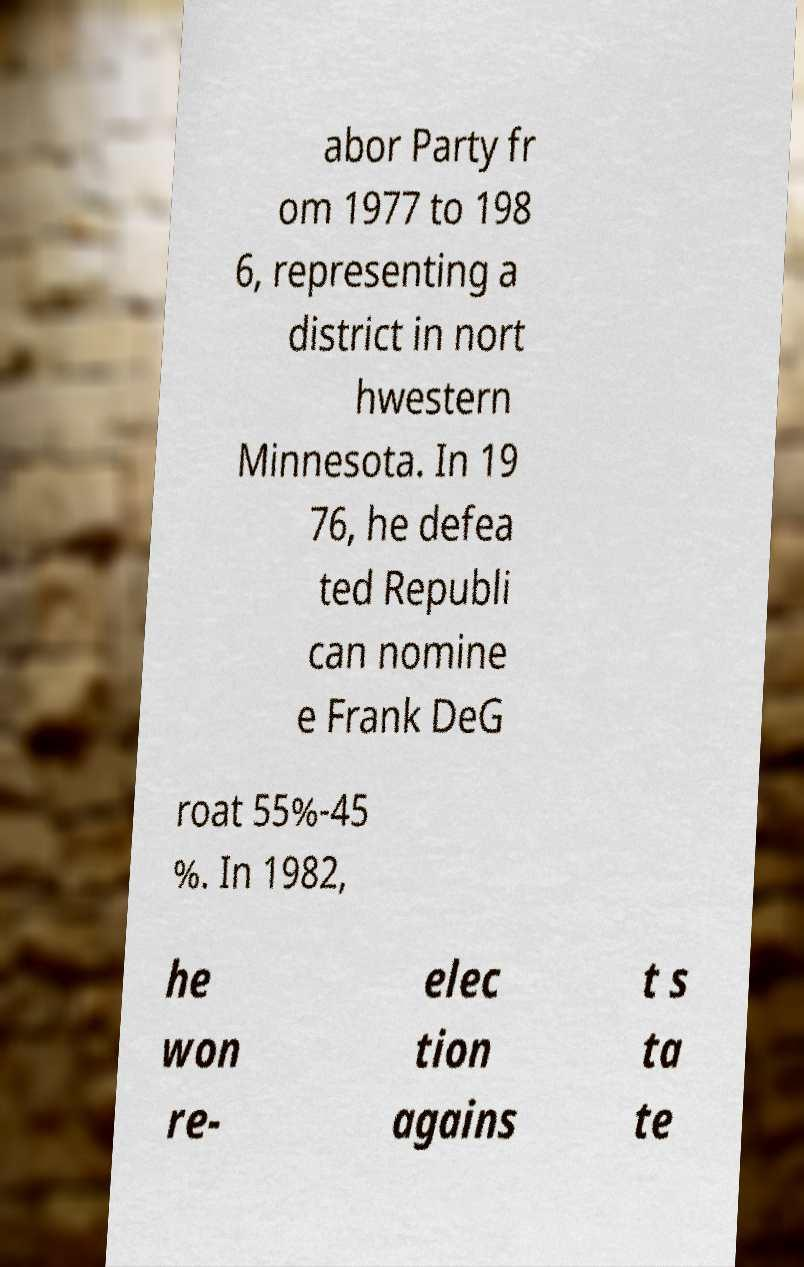There's text embedded in this image that I need extracted. Can you transcribe it verbatim? abor Party fr om 1977 to 198 6, representing a district in nort hwestern Minnesota. In 19 76, he defea ted Republi can nomine e Frank DeG roat 55%-45 %. In 1982, he won re- elec tion agains t s ta te 